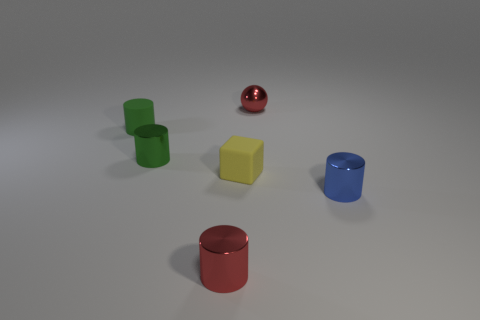Add 1 small green things. How many objects exist? 7 Subtract all red cylinders. How many cylinders are left? 3 Subtract all gray balls. How many green cylinders are left? 2 Subtract all blue cylinders. How many cylinders are left? 3 Subtract all cylinders. How many objects are left? 2 Subtract all small gray rubber things. Subtract all tiny rubber cylinders. How many objects are left? 5 Add 3 red metal things. How many red metal things are left? 5 Add 1 green matte spheres. How many green matte spheres exist? 1 Subtract 2 green cylinders. How many objects are left? 4 Subtract all green cylinders. Subtract all red blocks. How many cylinders are left? 2 